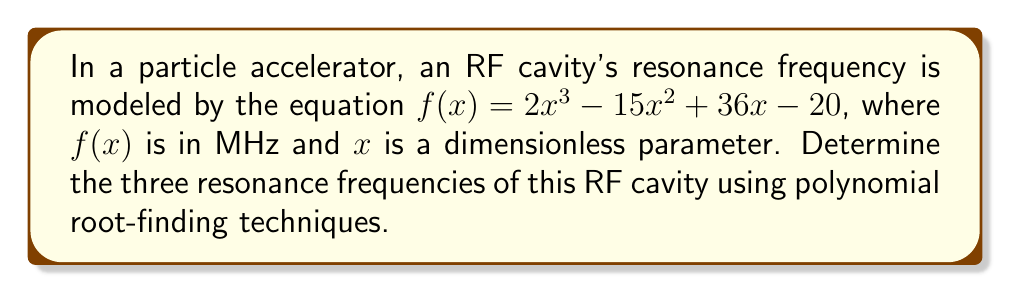Provide a solution to this math problem. To find the resonance frequencies, we need to find the roots of the polynomial equation:

1) First, let's factor out the greatest common factor (GCF):
   $f(x) = 2x^3 - 15x^2 + 36x - 20$
   There is no common factor, so we proceed to the next step.

2) Check if there are any rational roots using the rational root theorem:
   Possible rational roots: $\pm 1, \pm 2, \pm 4, \pm 5, \pm 10, \pm 20$

3) Using synthetic division, we can test these potential roots:
   $x = 1$ works: $2(1)^3 - 15(1)^2 + 36(1) - 20 = 2 - 15 + 36 - 20 = 3$

4) Factoring out $(x-1)$:
   $f(x) = (x-1)(2x^2 - 13x + 20)$

5) For the quadratic factor, we can use the quadratic formula:
   $x = \frac{-b \pm \sqrt{b^2 - 4ac}}{2a}$
   
   Where $a=2$, $b=-13$, and $c=20$

6) Substituting into the quadratic formula:
   $x = \frac{13 \pm \sqrt{(-13)^2 - 4(2)(20)}}{2(2)}$
   $x = \frac{13 \pm \sqrt{169 - 160}}{4}$
   $x = \frac{13 \pm 3}{4}$

7) This gives us two more roots:
   $x = \frac{13 + 3}{4} = 4$ and $x = \frac{13 - 3}{4} = \frac{5}{2}$

Therefore, the three roots (and thus the resonance frequencies) are $1$ MHz, $4$ MHz, and $2.5$ MHz.
Answer: $1$ MHz, $2.5$ MHz, $4$ MHz 